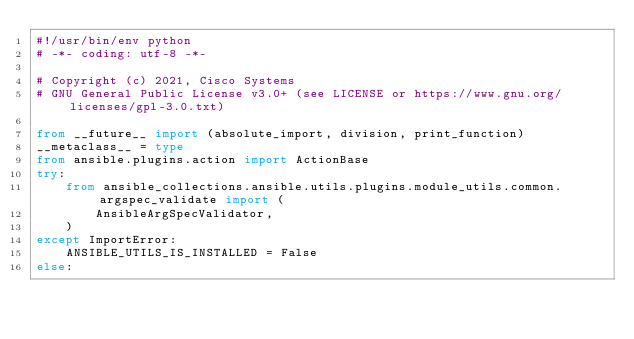Convert code to text. <code><loc_0><loc_0><loc_500><loc_500><_Python_>#!/usr/bin/env python
# -*- coding: utf-8 -*-

# Copyright (c) 2021, Cisco Systems
# GNU General Public License v3.0+ (see LICENSE or https://www.gnu.org/licenses/gpl-3.0.txt)

from __future__ import (absolute_import, division, print_function)
__metaclass__ = type
from ansible.plugins.action import ActionBase
try:
    from ansible_collections.ansible.utils.plugins.module_utils.common.argspec_validate import (
        AnsibleArgSpecValidator,
    )
except ImportError:
    ANSIBLE_UTILS_IS_INSTALLED = False
else:</code> 